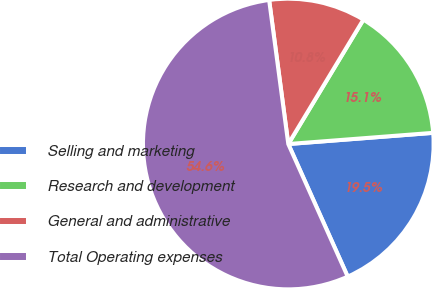Convert chart to OTSL. <chart><loc_0><loc_0><loc_500><loc_500><pie_chart><fcel>Selling and marketing<fcel>Research and development<fcel>General and administrative<fcel>Total Operating expenses<nl><fcel>19.52%<fcel>15.13%<fcel>10.75%<fcel>54.6%<nl></chart> 